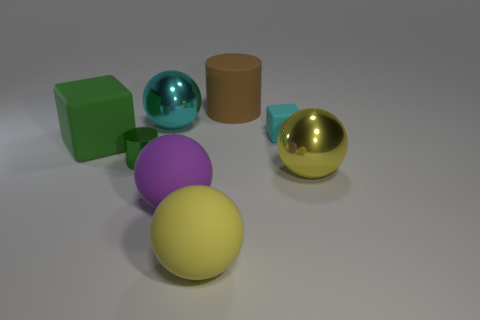Subtract all big cyan balls. How many balls are left? 3 Add 2 brown rubber things. How many objects exist? 10 Subtract 2 blocks. How many blocks are left? 0 Subtract all cyan balls. How many balls are left? 3 Subtract all brown cylinders. How many yellow spheres are left? 2 Add 6 small cyan metallic cylinders. How many small cyan metallic cylinders exist? 6 Subtract 1 cyan spheres. How many objects are left? 7 Subtract all brown blocks. Subtract all red cylinders. How many blocks are left? 2 Subtract all large gray matte things. Subtract all big metal balls. How many objects are left? 6 Add 1 yellow metal spheres. How many yellow metal spheres are left? 2 